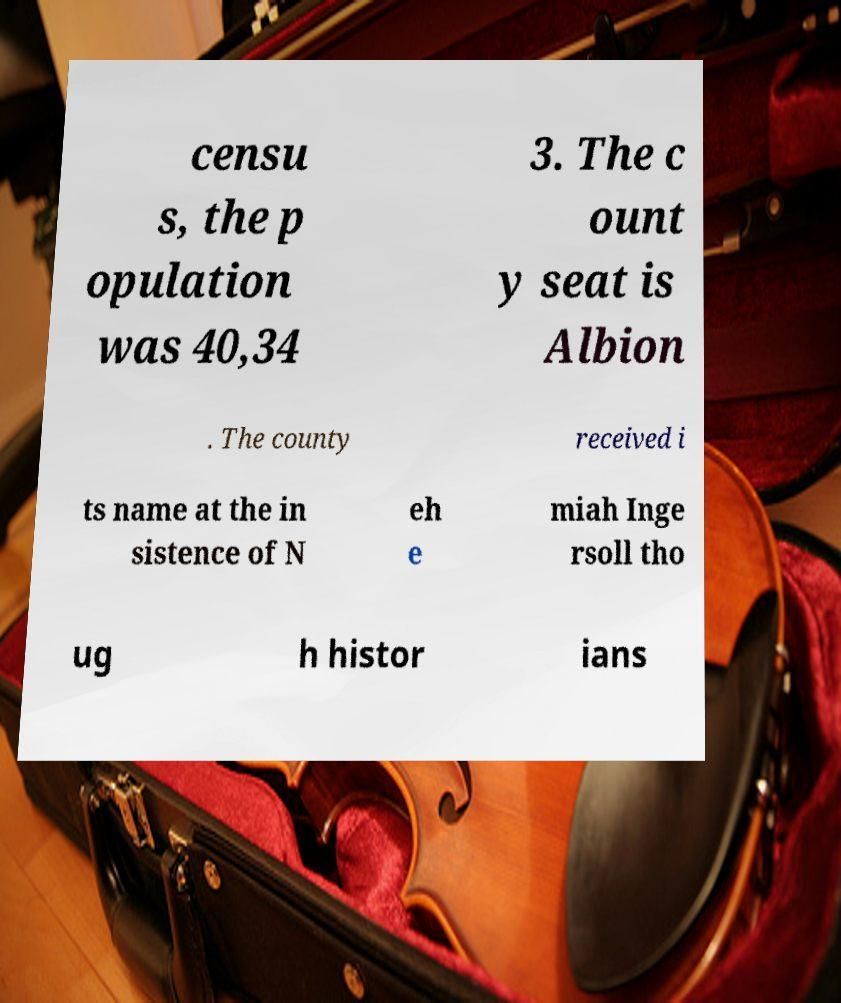I need the written content from this picture converted into text. Can you do that? censu s, the p opulation was 40,34 3. The c ount y seat is Albion . The county received i ts name at the in sistence of N eh e miah Inge rsoll tho ug h histor ians 